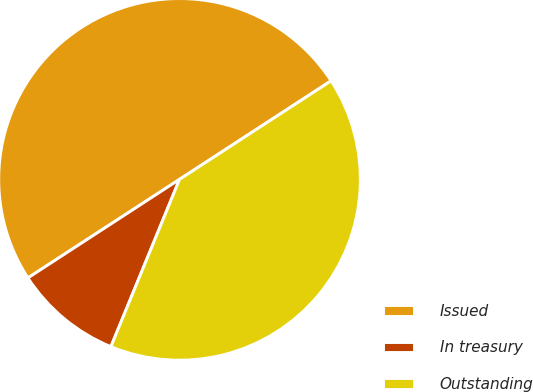Convert chart. <chart><loc_0><loc_0><loc_500><loc_500><pie_chart><fcel>Issued<fcel>In treasury<fcel>Outstanding<nl><fcel>50.0%<fcel>9.63%<fcel>40.37%<nl></chart> 